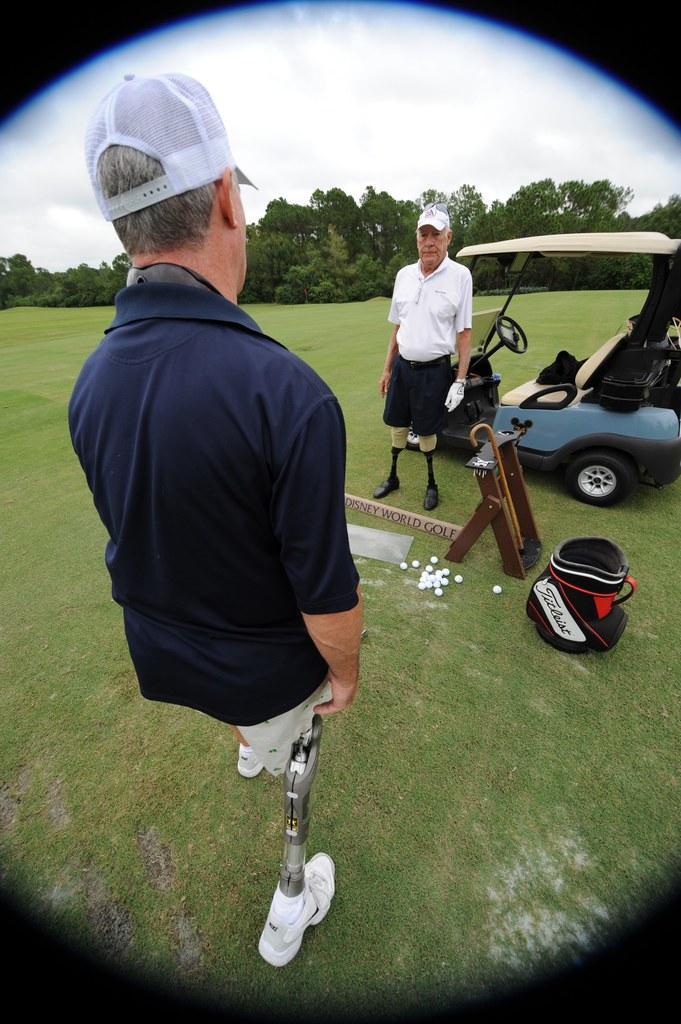Describe this image in one or two sentences. In this image there are two persons wearing white cap and t-shirt. They both are having artificial legs. Here there is a vehicle. Here there are few balls. In the background there are trees. The picture is clicked in a grass field. 